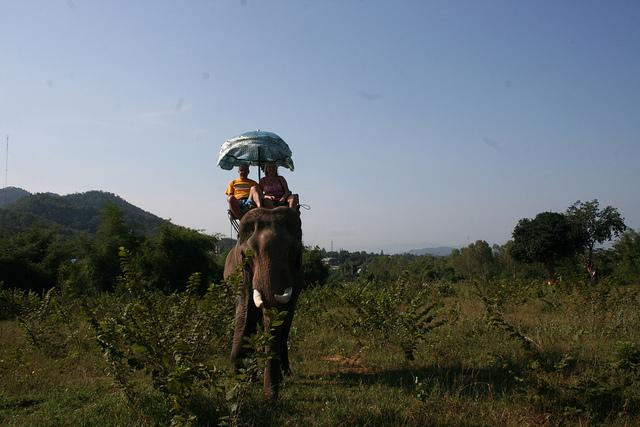What are they riding?
Short answer required. Elephant. How many trees?
Keep it brief. Several. Are there any elephants in the photo?
Answer briefly. Yes. Does the elephant have tusks?
Be succinct. Yes. What is the man riding?
Concise answer only. Elephant. Is the animal bored?
Quick response, please. No. Is he touching the ground?
Write a very short answer. No. 